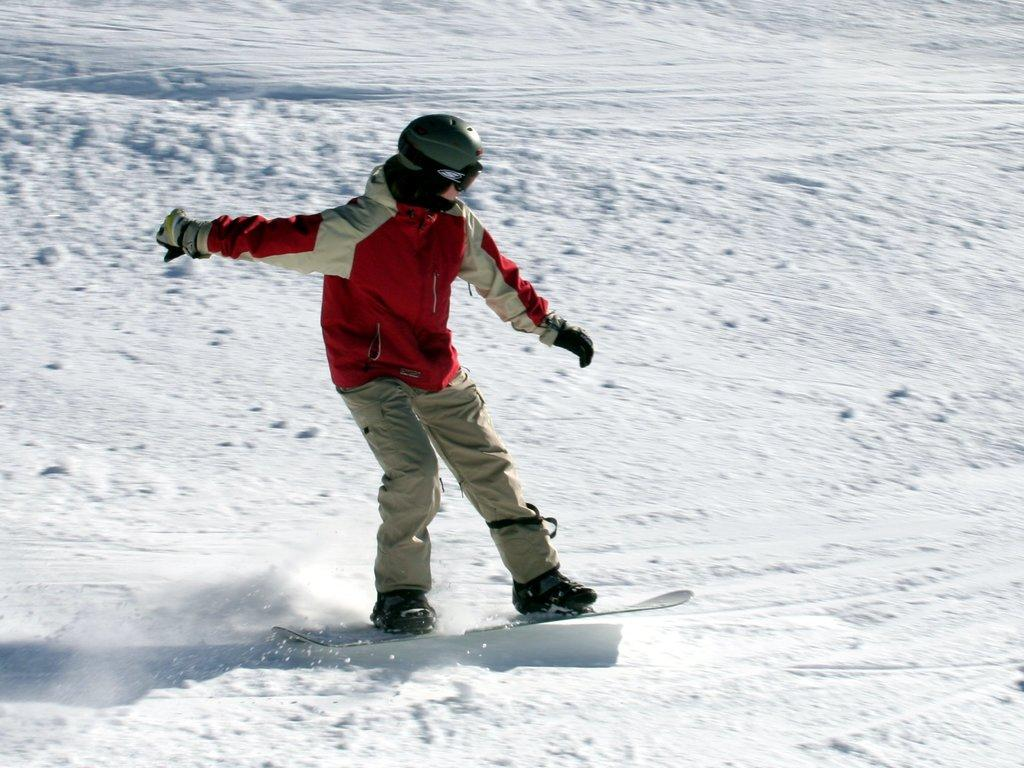Who or what is the main subject in the image? There is a person in the image. What is the person doing in the image? The person is riding on a ski board. What type of environment is depicted in the image? There is snow visible in the background of the image. What color is the shirt the moon is wearing in the image? There is no moon present in the image, and therefore no shirt to describe. 